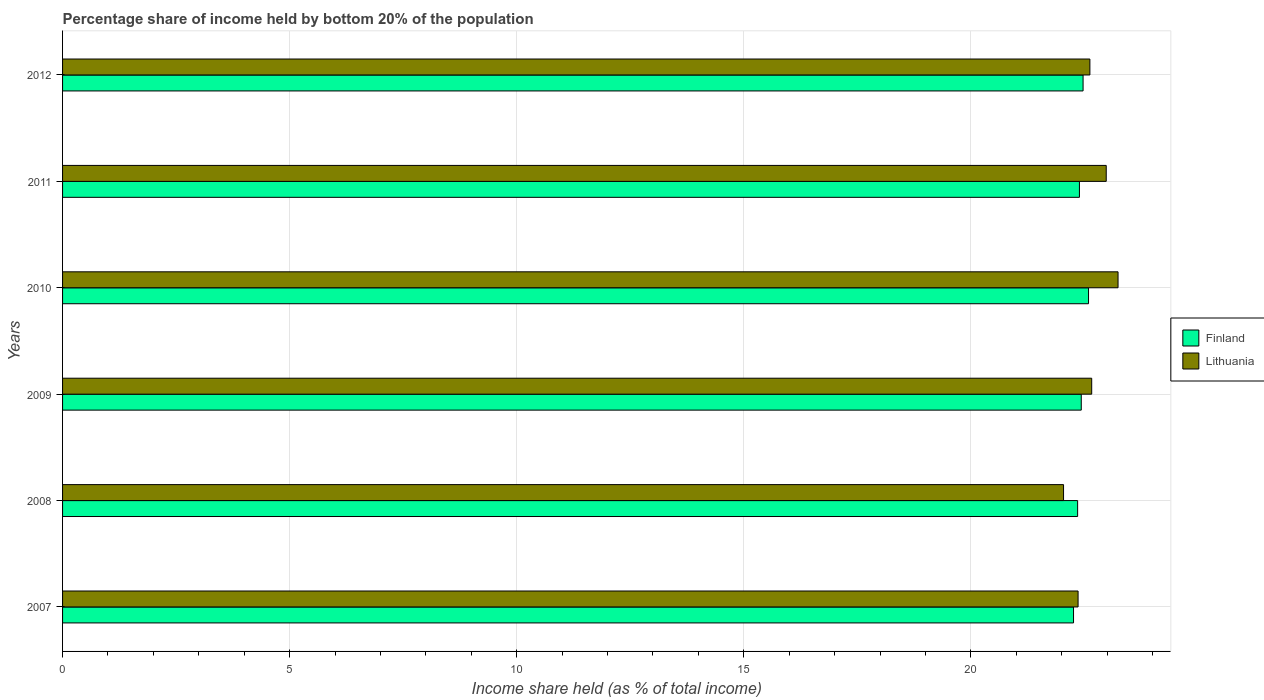How many different coloured bars are there?
Your answer should be very brief. 2. Are the number of bars per tick equal to the number of legend labels?
Offer a terse response. Yes. Are the number of bars on each tick of the Y-axis equal?
Your answer should be very brief. Yes. How many bars are there on the 4th tick from the top?
Your answer should be compact. 2. How many bars are there on the 3rd tick from the bottom?
Give a very brief answer. 2. In how many cases, is the number of bars for a given year not equal to the number of legend labels?
Offer a terse response. 0. What is the share of income held by bottom 20% of the population in Lithuania in 2012?
Ensure brevity in your answer.  22.62. Across all years, what is the maximum share of income held by bottom 20% of the population in Lithuania?
Offer a terse response. 23.24. Across all years, what is the minimum share of income held by bottom 20% of the population in Finland?
Your answer should be very brief. 22.26. In which year was the share of income held by bottom 20% of the population in Lithuania minimum?
Your response must be concise. 2008. What is the total share of income held by bottom 20% of the population in Lithuania in the graph?
Your response must be concise. 135.9. What is the difference between the share of income held by bottom 20% of the population in Finland in 2011 and that in 2012?
Your answer should be compact. -0.08. What is the difference between the share of income held by bottom 20% of the population in Finland in 2010 and the share of income held by bottom 20% of the population in Lithuania in 2011?
Offer a very short reply. -0.39. What is the average share of income held by bottom 20% of the population in Lithuania per year?
Offer a very short reply. 22.65. In the year 2009, what is the difference between the share of income held by bottom 20% of the population in Lithuania and share of income held by bottom 20% of the population in Finland?
Ensure brevity in your answer.  0.23. In how many years, is the share of income held by bottom 20% of the population in Lithuania greater than 16 %?
Your answer should be very brief. 6. What is the ratio of the share of income held by bottom 20% of the population in Finland in 2009 to that in 2010?
Ensure brevity in your answer.  0.99. Is the share of income held by bottom 20% of the population in Lithuania in 2008 less than that in 2010?
Your answer should be compact. Yes. Is the difference between the share of income held by bottom 20% of the population in Lithuania in 2007 and 2012 greater than the difference between the share of income held by bottom 20% of the population in Finland in 2007 and 2012?
Your answer should be compact. No. What is the difference between the highest and the second highest share of income held by bottom 20% of the population in Finland?
Keep it short and to the point. 0.12. What is the difference between the highest and the lowest share of income held by bottom 20% of the population in Finland?
Keep it short and to the point. 0.33. In how many years, is the share of income held by bottom 20% of the population in Finland greater than the average share of income held by bottom 20% of the population in Finland taken over all years?
Make the answer very short. 3. Is the sum of the share of income held by bottom 20% of the population in Finland in 2007 and 2009 greater than the maximum share of income held by bottom 20% of the population in Lithuania across all years?
Keep it short and to the point. Yes. How many bars are there?
Provide a short and direct response. 12. What is the difference between two consecutive major ticks on the X-axis?
Your response must be concise. 5. Are the values on the major ticks of X-axis written in scientific E-notation?
Provide a succinct answer. No. Does the graph contain grids?
Provide a short and direct response. Yes. Where does the legend appear in the graph?
Offer a terse response. Center right. What is the title of the graph?
Provide a succinct answer. Percentage share of income held by bottom 20% of the population. What is the label or title of the X-axis?
Provide a succinct answer. Income share held (as % of total income). What is the label or title of the Y-axis?
Your answer should be very brief. Years. What is the Income share held (as % of total income) of Finland in 2007?
Make the answer very short. 22.26. What is the Income share held (as % of total income) of Lithuania in 2007?
Offer a very short reply. 22.36. What is the Income share held (as % of total income) of Finland in 2008?
Your answer should be very brief. 22.35. What is the Income share held (as % of total income) in Lithuania in 2008?
Provide a short and direct response. 22.04. What is the Income share held (as % of total income) in Finland in 2009?
Keep it short and to the point. 22.43. What is the Income share held (as % of total income) in Lithuania in 2009?
Offer a very short reply. 22.66. What is the Income share held (as % of total income) in Finland in 2010?
Your answer should be very brief. 22.59. What is the Income share held (as % of total income) in Lithuania in 2010?
Make the answer very short. 23.24. What is the Income share held (as % of total income) of Finland in 2011?
Give a very brief answer. 22.39. What is the Income share held (as % of total income) in Lithuania in 2011?
Keep it short and to the point. 22.98. What is the Income share held (as % of total income) of Finland in 2012?
Your answer should be very brief. 22.47. What is the Income share held (as % of total income) of Lithuania in 2012?
Your answer should be compact. 22.62. Across all years, what is the maximum Income share held (as % of total income) of Finland?
Provide a short and direct response. 22.59. Across all years, what is the maximum Income share held (as % of total income) in Lithuania?
Provide a short and direct response. 23.24. Across all years, what is the minimum Income share held (as % of total income) of Finland?
Offer a terse response. 22.26. Across all years, what is the minimum Income share held (as % of total income) in Lithuania?
Give a very brief answer. 22.04. What is the total Income share held (as % of total income) in Finland in the graph?
Keep it short and to the point. 134.49. What is the total Income share held (as % of total income) of Lithuania in the graph?
Give a very brief answer. 135.9. What is the difference between the Income share held (as % of total income) of Finland in 2007 and that in 2008?
Keep it short and to the point. -0.09. What is the difference between the Income share held (as % of total income) in Lithuania in 2007 and that in 2008?
Provide a short and direct response. 0.32. What is the difference between the Income share held (as % of total income) in Finland in 2007 and that in 2009?
Give a very brief answer. -0.17. What is the difference between the Income share held (as % of total income) of Lithuania in 2007 and that in 2009?
Provide a succinct answer. -0.3. What is the difference between the Income share held (as % of total income) in Finland in 2007 and that in 2010?
Make the answer very short. -0.33. What is the difference between the Income share held (as % of total income) in Lithuania in 2007 and that in 2010?
Your answer should be very brief. -0.88. What is the difference between the Income share held (as % of total income) in Finland in 2007 and that in 2011?
Your answer should be very brief. -0.13. What is the difference between the Income share held (as % of total income) in Lithuania in 2007 and that in 2011?
Your response must be concise. -0.62. What is the difference between the Income share held (as % of total income) of Finland in 2007 and that in 2012?
Your response must be concise. -0.21. What is the difference between the Income share held (as % of total income) in Lithuania in 2007 and that in 2012?
Ensure brevity in your answer.  -0.26. What is the difference between the Income share held (as % of total income) in Finland in 2008 and that in 2009?
Your answer should be compact. -0.08. What is the difference between the Income share held (as % of total income) of Lithuania in 2008 and that in 2009?
Offer a very short reply. -0.62. What is the difference between the Income share held (as % of total income) in Finland in 2008 and that in 2010?
Make the answer very short. -0.24. What is the difference between the Income share held (as % of total income) of Lithuania in 2008 and that in 2010?
Provide a succinct answer. -1.2. What is the difference between the Income share held (as % of total income) in Finland in 2008 and that in 2011?
Provide a short and direct response. -0.04. What is the difference between the Income share held (as % of total income) of Lithuania in 2008 and that in 2011?
Make the answer very short. -0.94. What is the difference between the Income share held (as % of total income) in Finland in 2008 and that in 2012?
Provide a short and direct response. -0.12. What is the difference between the Income share held (as % of total income) of Lithuania in 2008 and that in 2012?
Keep it short and to the point. -0.58. What is the difference between the Income share held (as % of total income) in Finland in 2009 and that in 2010?
Provide a succinct answer. -0.16. What is the difference between the Income share held (as % of total income) of Lithuania in 2009 and that in 2010?
Give a very brief answer. -0.58. What is the difference between the Income share held (as % of total income) of Finland in 2009 and that in 2011?
Make the answer very short. 0.04. What is the difference between the Income share held (as % of total income) in Lithuania in 2009 and that in 2011?
Your answer should be compact. -0.32. What is the difference between the Income share held (as % of total income) in Finland in 2009 and that in 2012?
Your response must be concise. -0.04. What is the difference between the Income share held (as % of total income) in Lithuania in 2010 and that in 2011?
Your answer should be compact. 0.26. What is the difference between the Income share held (as % of total income) in Finland in 2010 and that in 2012?
Offer a very short reply. 0.12. What is the difference between the Income share held (as % of total income) of Lithuania in 2010 and that in 2012?
Provide a short and direct response. 0.62. What is the difference between the Income share held (as % of total income) in Finland in 2011 and that in 2012?
Ensure brevity in your answer.  -0.08. What is the difference between the Income share held (as % of total income) in Lithuania in 2011 and that in 2012?
Your answer should be compact. 0.36. What is the difference between the Income share held (as % of total income) in Finland in 2007 and the Income share held (as % of total income) in Lithuania in 2008?
Offer a terse response. 0.22. What is the difference between the Income share held (as % of total income) in Finland in 2007 and the Income share held (as % of total income) in Lithuania in 2009?
Your answer should be compact. -0.4. What is the difference between the Income share held (as % of total income) of Finland in 2007 and the Income share held (as % of total income) of Lithuania in 2010?
Your response must be concise. -0.98. What is the difference between the Income share held (as % of total income) in Finland in 2007 and the Income share held (as % of total income) in Lithuania in 2011?
Your response must be concise. -0.72. What is the difference between the Income share held (as % of total income) of Finland in 2007 and the Income share held (as % of total income) of Lithuania in 2012?
Make the answer very short. -0.36. What is the difference between the Income share held (as % of total income) in Finland in 2008 and the Income share held (as % of total income) in Lithuania in 2009?
Offer a terse response. -0.31. What is the difference between the Income share held (as % of total income) of Finland in 2008 and the Income share held (as % of total income) of Lithuania in 2010?
Ensure brevity in your answer.  -0.89. What is the difference between the Income share held (as % of total income) of Finland in 2008 and the Income share held (as % of total income) of Lithuania in 2011?
Your answer should be compact. -0.63. What is the difference between the Income share held (as % of total income) in Finland in 2008 and the Income share held (as % of total income) in Lithuania in 2012?
Your response must be concise. -0.27. What is the difference between the Income share held (as % of total income) of Finland in 2009 and the Income share held (as % of total income) of Lithuania in 2010?
Offer a terse response. -0.81. What is the difference between the Income share held (as % of total income) in Finland in 2009 and the Income share held (as % of total income) in Lithuania in 2011?
Your answer should be very brief. -0.55. What is the difference between the Income share held (as % of total income) in Finland in 2009 and the Income share held (as % of total income) in Lithuania in 2012?
Your response must be concise. -0.19. What is the difference between the Income share held (as % of total income) in Finland in 2010 and the Income share held (as % of total income) in Lithuania in 2011?
Keep it short and to the point. -0.39. What is the difference between the Income share held (as % of total income) of Finland in 2010 and the Income share held (as % of total income) of Lithuania in 2012?
Make the answer very short. -0.03. What is the difference between the Income share held (as % of total income) in Finland in 2011 and the Income share held (as % of total income) in Lithuania in 2012?
Give a very brief answer. -0.23. What is the average Income share held (as % of total income) of Finland per year?
Your response must be concise. 22.41. What is the average Income share held (as % of total income) in Lithuania per year?
Offer a very short reply. 22.65. In the year 2008, what is the difference between the Income share held (as % of total income) of Finland and Income share held (as % of total income) of Lithuania?
Make the answer very short. 0.31. In the year 2009, what is the difference between the Income share held (as % of total income) of Finland and Income share held (as % of total income) of Lithuania?
Your answer should be compact. -0.23. In the year 2010, what is the difference between the Income share held (as % of total income) in Finland and Income share held (as % of total income) in Lithuania?
Your answer should be compact. -0.65. In the year 2011, what is the difference between the Income share held (as % of total income) of Finland and Income share held (as % of total income) of Lithuania?
Give a very brief answer. -0.59. In the year 2012, what is the difference between the Income share held (as % of total income) in Finland and Income share held (as % of total income) in Lithuania?
Keep it short and to the point. -0.15. What is the ratio of the Income share held (as % of total income) in Lithuania in 2007 to that in 2008?
Your answer should be very brief. 1.01. What is the ratio of the Income share held (as % of total income) of Lithuania in 2007 to that in 2009?
Ensure brevity in your answer.  0.99. What is the ratio of the Income share held (as % of total income) in Finland in 2007 to that in 2010?
Your answer should be compact. 0.99. What is the ratio of the Income share held (as % of total income) in Lithuania in 2007 to that in 2010?
Your answer should be compact. 0.96. What is the ratio of the Income share held (as % of total income) in Finland in 2007 to that in 2011?
Offer a terse response. 0.99. What is the ratio of the Income share held (as % of total income) of Lithuania in 2007 to that in 2011?
Your response must be concise. 0.97. What is the ratio of the Income share held (as % of total income) in Lithuania in 2008 to that in 2009?
Ensure brevity in your answer.  0.97. What is the ratio of the Income share held (as % of total income) of Finland in 2008 to that in 2010?
Give a very brief answer. 0.99. What is the ratio of the Income share held (as % of total income) in Lithuania in 2008 to that in 2010?
Give a very brief answer. 0.95. What is the ratio of the Income share held (as % of total income) in Finland in 2008 to that in 2011?
Your answer should be compact. 1. What is the ratio of the Income share held (as % of total income) in Lithuania in 2008 to that in 2011?
Your answer should be compact. 0.96. What is the ratio of the Income share held (as % of total income) in Lithuania in 2008 to that in 2012?
Provide a succinct answer. 0.97. What is the ratio of the Income share held (as % of total income) in Lithuania in 2009 to that in 2010?
Offer a very short reply. 0.97. What is the ratio of the Income share held (as % of total income) of Lithuania in 2009 to that in 2011?
Provide a succinct answer. 0.99. What is the ratio of the Income share held (as % of total income) of Finland in 2009 to that in 2012?
Offer a terse response. 1. What is the ratio of the Income share held (as % of total income) of Lithuania in 2009 to that in 2012?
Offer a very short reply. 1. What is the ratio of the Income share held (as % of total income) in Finland in 2010 to that in 2011?
Give a very brief answer. 1.01. What is the ratio of the Income share held (as % of total income) of Lithuania in 2010 to that in 2011?
Provide a succinct answer. 1.01. What is the ratio of the Income share held (as % of total income) in Finland in 2010 to that in 2012?
Provide a succinct answer. 1.01. What is the ratio of the Income share held (as % of total income) in Lithuania in 2010 to that in 2012?
Give a very brief answer. 1.03. What is the ratio of the Income share held (as % of total income) in Lithuania in 2011 to that in 2012?
Ensure brevity in your answer.  1.02. What is the difference between the highest and the second highest Income share held (as % of total income) in Finland?
Offer a terse response. 0.12. What is the difference between the highest and the second highest Income share held (as % of total income) in Lithuania?
Give a very brief answer. 0.26. What is the difference between the highest and the lowest Income share held (as % of total income) in Finland?
Make the answer very short. 0.33. 